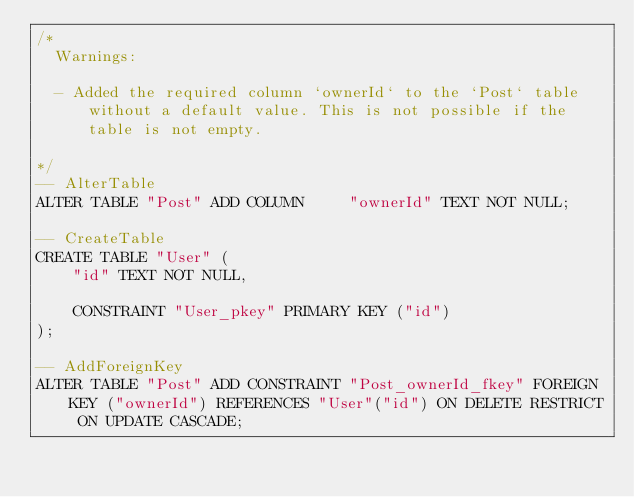<code> <loc_0><loc_0><loc_500><loc_500><_SQL_>/*
  Warnings:

  - Added the required column `ownerId` to the `Post` table without a default value. This is not possible if the table is not empty.

*/
-- AlterTable
ALTER TABLE "Post" ADD COLUMN     "ownerId" TEXT NOT NULL;

-- CreateTable
CREATE TABLE "User" (
    "id" TEXT NOT NULL,

    CONSTRAINT "User_pkey" PRIMARY KEY ("id")
);

-- AddForeignKey
ALTER TABLE "Post" ADD CONSTRAINT "Post_ownerId_fkey" FOREIGN KEY ("ownerId") REFERENCES "User"("id") ON DELETE RESTRICT ON UPDATE CASCADE;
</code> 